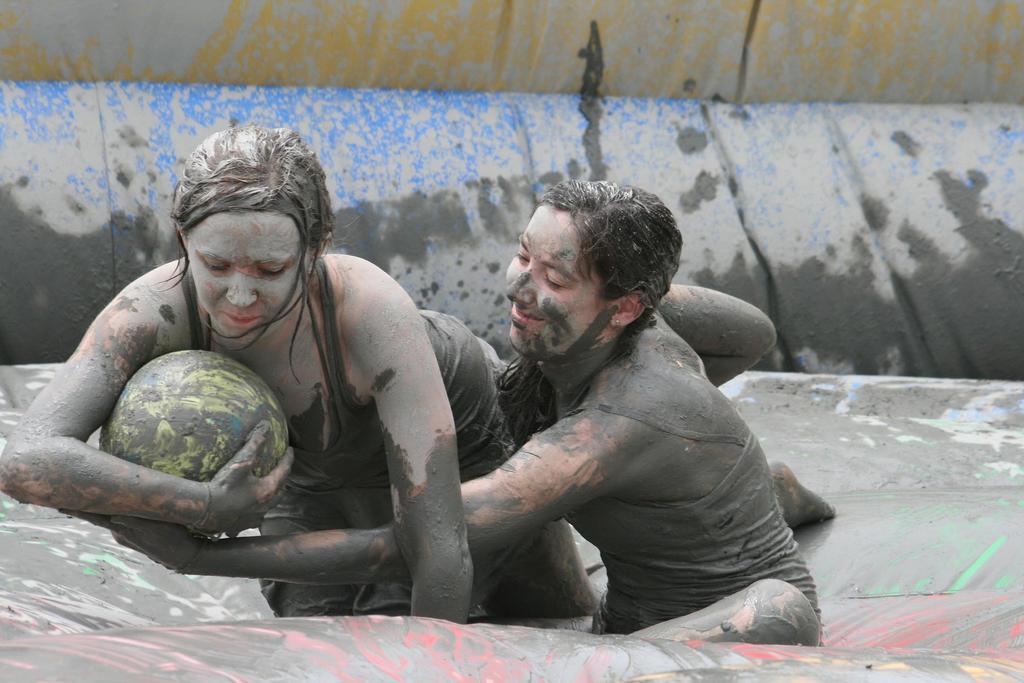How would you summarize this image in a sentence or two? Here in this picture we can see two women present over a place and both of them are playing a game as we can see the woman on the left side is holding a ball and the other woman is trying to grab the ball and both of them are smiling and we can see they are covered with mud over there. 